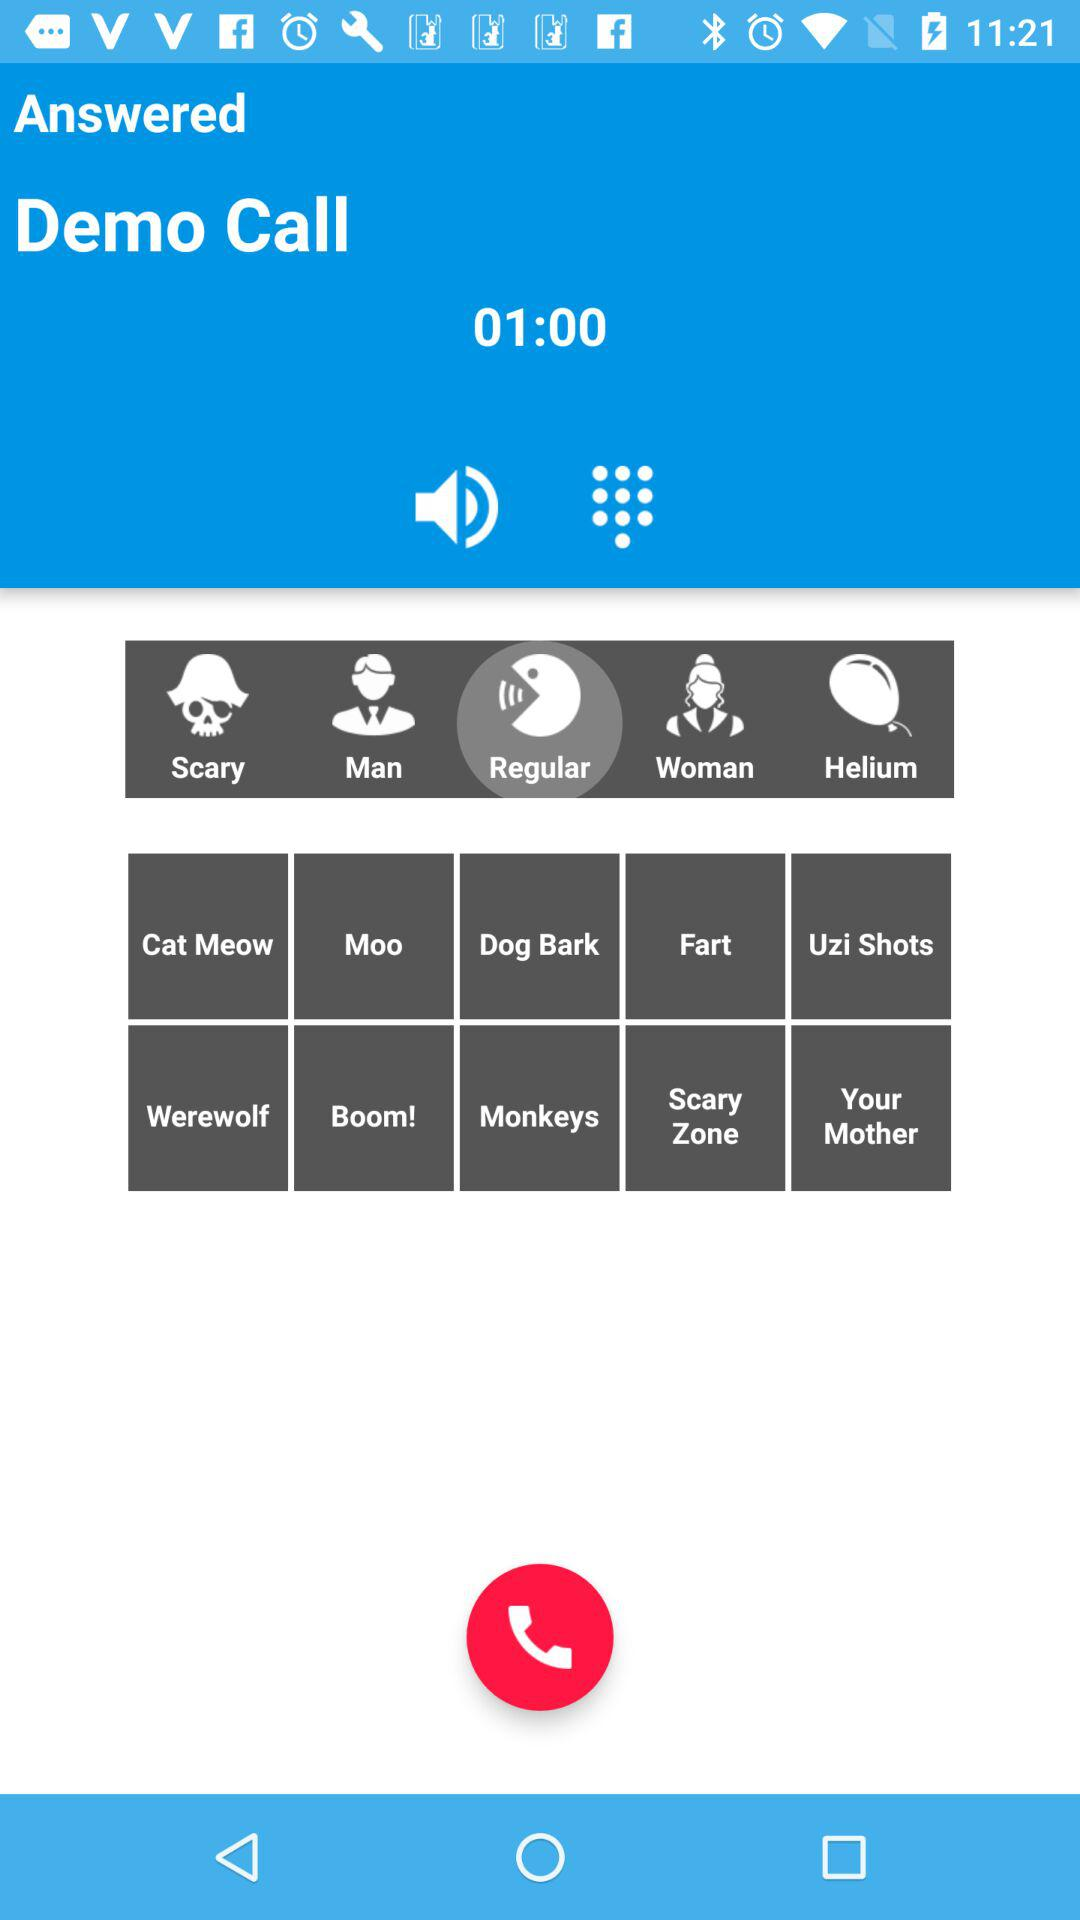What is the duration of the demo call? The duration is 1 minute. 